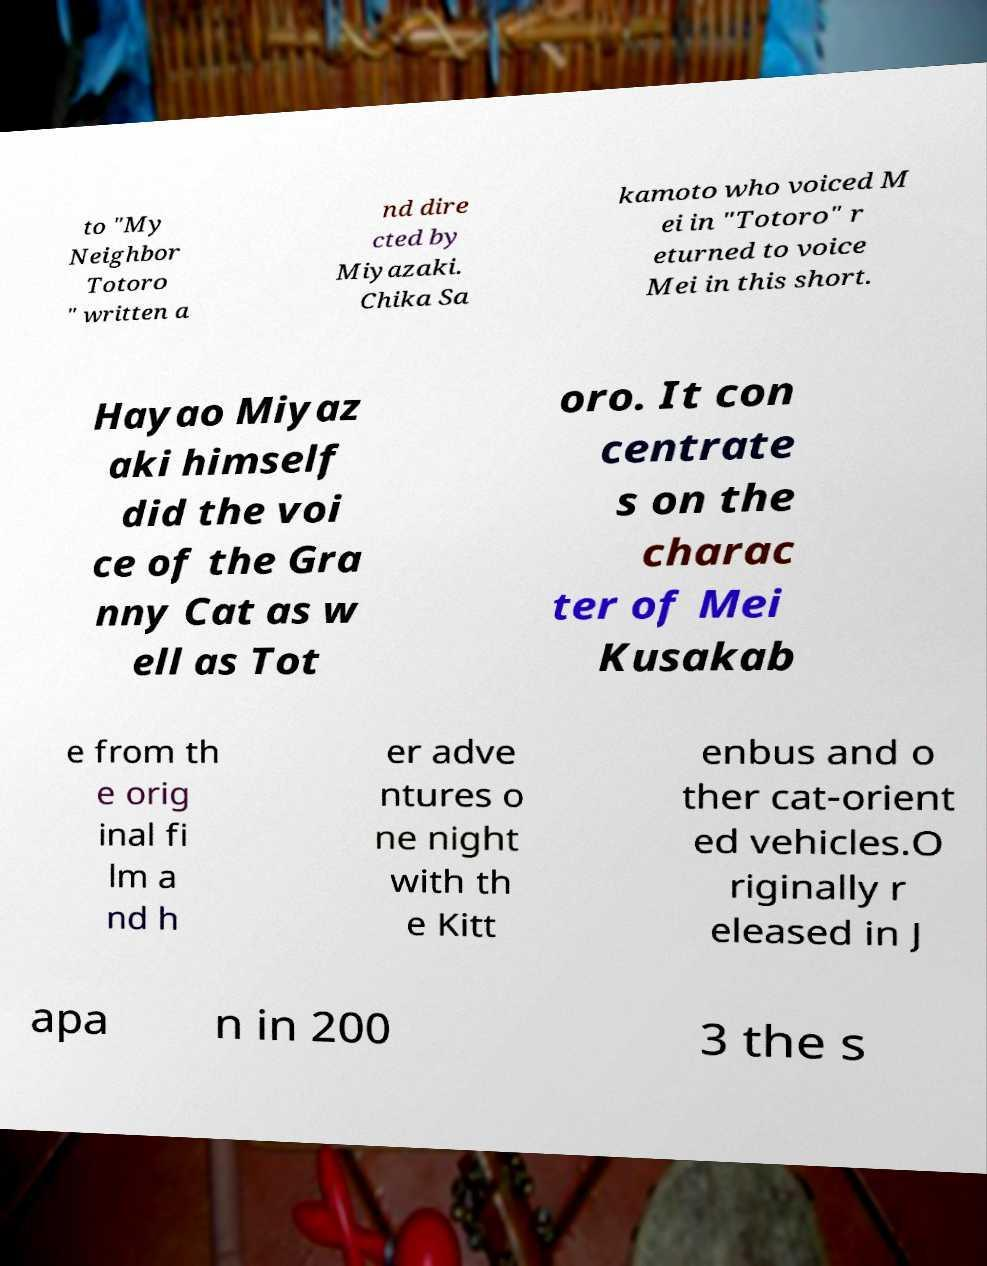There's text embedded in this image that I need extracted. Can you transcribe it verbatim? to "My Neighbor Totoro " written a nd dire cted by Miyazaki. Chika Sa kamoto who voiced M ei in "Totoro" r eturned to voice Mei in this short. Hayao Miyaz aki himself did the voi ce of the Gra nny Cat as w ell as Tot oro. It con centrate s on the charac ter of Mei Kusakab e from th e orig inal fi lm a nd h er adve ntures o ne night with th e Kitt enbus and o ther cat-orient ed vehicles.O riginally r eleased in J apa n in 200 3 the s 